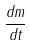Convert formula to latex. <formula><loc_0><loc_0><loc_500><loc_500>\frac { d m } { d t }</formula> 